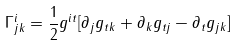Convert formula to latex. <formula><loc_0><loc_0><loc_500><loc_500>\Gamma ^ { i } _ { j k } = \frac { 1 } { 2 } g ^ { i t } [ \partial _ { j } g _ { t k } + \partial _ { k } g _ { t j } - \partial _ { t } g _ { j k } ]</formula> 